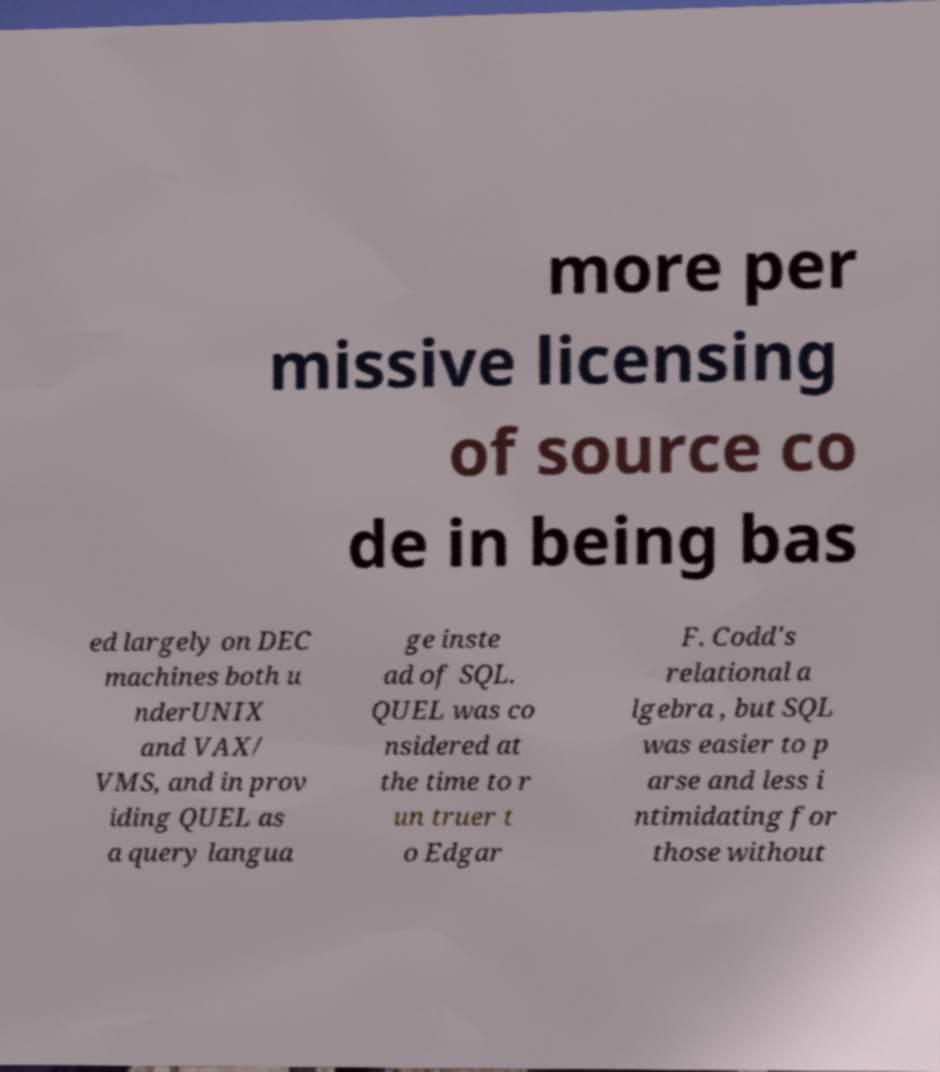Can you accurately transcribe the text from the provided image for me? more per missive licensing of source co de in being bas ed largely on DEC machines both u nderUNIX and VAX/ VMS, and in prov iding QUEL as a query langua ge inste ad of SQL. QUEL was co nsidered at the time to r un truer t o Edgar F. Codd's relational a lgebra , but SQL was easier to p arse and less i ntimidating for those without 